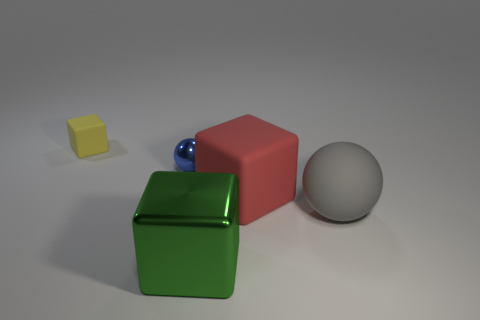Add 1 tiny green shiny objects. How many objects exist? 6 Subtract all blocks. How many objects are left? 2 Subtract all tiny yellow blocks. How many blocks are left? 2 Add 5 cyan metallic spheres. How many cyan metallic spheres exist? 5 Subtract all yellow blocks. How many blocks are left? 2 Subtract 0 blue cylinders. How many objects are left? 5 Subtract 2 blocks. How many blocks are left? 1 Subtract all yellow spheres. Subtract all yellow cylinders. How many spheres are left? 2 Subtract all red cubes. How many yellow spheres are left? 0 Subtract all small spheres. Subtract all large red blocks. How many objects are left? 3 